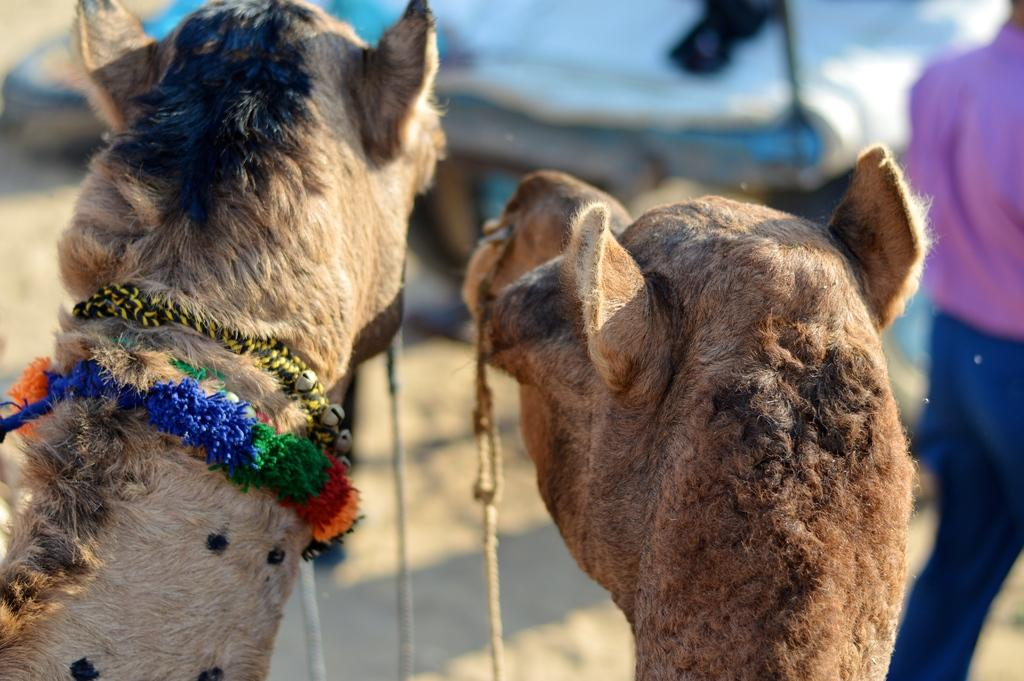How many camels are in the image? There are two camels in the image. Can you describe any distinguishing features of the camels? One of the camels has a band around its neck. Is there anyone else present in the image besides the camels? Yes, there is a person next to the camels. What type of appliance is being used by the camels in the image? There are no appliances present in the image; it features two camels and a person. Can you tell me how many ears of corn are visible in the image? There are no ears of corn present in the image. 